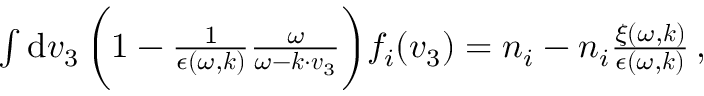<formula> <loc_0><loc_0><loc_500><loc_500>\begin{array} { r } { \int d v _ { 3 } \, \left ( 1 - \frac { 1 } { \epsilon ( \omega , k ) } \frac { \omega } { \omega - k \cdot v _ { 3 } } \right ) f _ { i } ( v _ { 3 } ) = n _ { i } - n _ { i } \frac { \xi ( \omega , k ) } { \epsilon ( \omega , k ) } \, , } \end{array}</formula> 